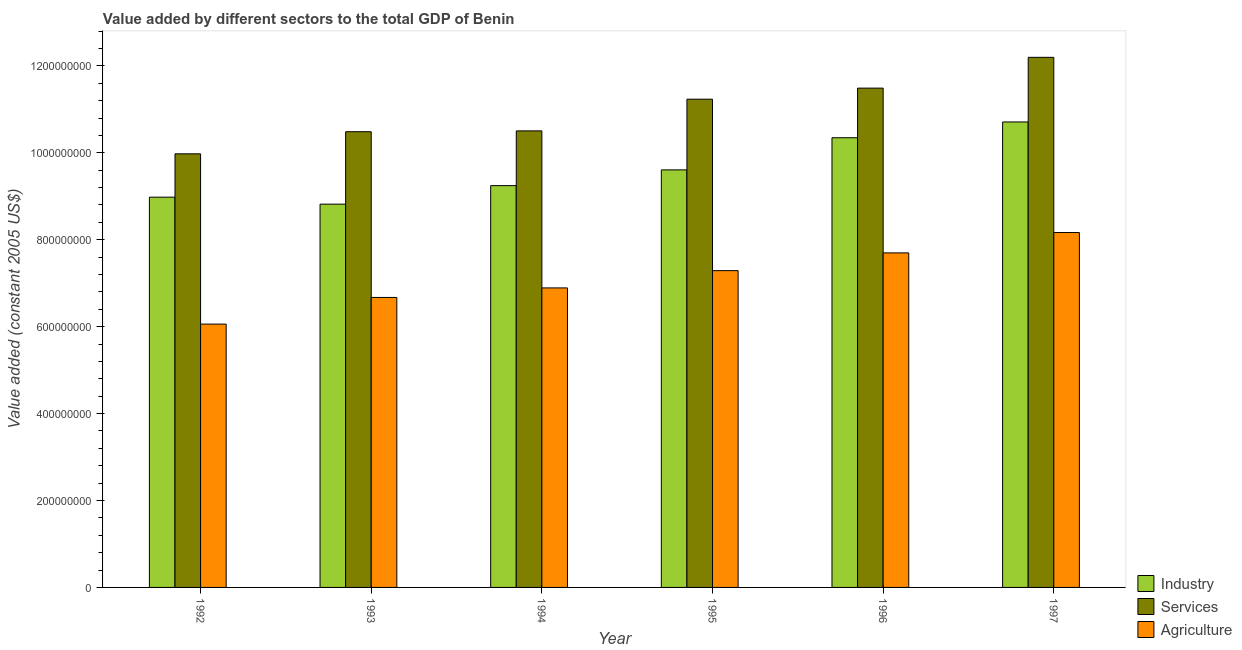How many different coloured bars are there?
Offer a very short reply. 3. Are the number of bars per tick equal to the number of legend labels?
Keep it short and to the point. Yes. What is the label of the 5th group of bars from the left?
Keep it short and to the point. 1996. What is the value added by agricultural sector in 1992?
Make the answer very short. 6.06e+08. Across all years, what is the maximum value added by agricultural sector?
Ensure brevity in your answer.  8.17e+08. Across all years, what is the minimum value added by services?
Give a very brief answer. 9.98e+08. In which year was the value added by industrial sector maximum?
Keep it short and to the point. 1997. In which year was the value added by industrial sector minimum?
Keep it short and to the point. 1993. What is the total value added by services in the graph?
Make the answer very short. 6.59e+09. What is the difference between the value added by agricultural sector in 1994 and that in 1995?
Offer a terse response. -3.97e+07. What is the difference between the value added by industrial sector in 1993 and the value added by services in 1995?
Provide a short and direct response. -7.89e+07. What is the average value added by industrial sector per year?
Keep it short and to the point. 9.62e+08. In the year 1993, what is the difference between the value added by agricultural sector and value added by industrial sector?
Ensure brevity in your answer.  0. In how many years, is the value added by industrial sector greater than 280000000 US$?
Ensure brevity in your answer.  6. What is the ratio of the value added by services in 1994 to that in 1996?
Keep it short and to the point. 0.91. What is the difference between the highest and the second highest value added by agricultural sector?
Your response must be concise. 4.68e+07. What is the difference between the highest and the lowest value added by industrial sector?
Keep it short and to the point. 1.89e+08. In how many years, is the value added by agricultural sector greater than the average value added by agricultural sector taken over all years?
Your answer should be compact. 3. What does the 2nd bar from the left in 1996 represents?
Provide a short and direct response. Services. What does the 3rd bar from the right in 1994 represents?
Provide a succinct answer. Industry. How are the legend labels stacked?
Ensure brevity in your answer.  Vertical. What is the title of the graph?
Your answer should be compact. Value added by different sectors to the total GDP of Benin. Does "New Zealand" appear as one of the legend labels in the graph?
Provide a short and direct response. No. What is the label or title of the X-axis?
Offer a terse response. Year. What is the label or title of the Y-axis?
Provide a succinct answer. Value added (constant 2005 US$). What is the Value added (constant 2005 US$) in Industry in 1992?
Make the answer very short. 8.98e+08. What is the Value added (constant 2005 US$) of Services in 1992?
Keep it short and to the point. 9.98e+08. What is the Value added (constant 2005 US$) of Agriculture in 1992?
Ensure brevity in your answer.  6.06e+08. What is the Value added (constant 2005 US$) of Industry in 1993?
Keep it short and to the point. 8.82e+08. What is the Value added (constant 2005 US$) of Services in 1993?
Make the answer very short. 1.05e+09. What is the Value added (constant 2005 US$) in Agriculture in 1993?
Make the answer very short. 6.67e+08. What is the Value added (constant 2005 US$) in Industry in 1994?
Your response must be concise. 9.25e+08. What is the Value added (constant 2005 US$) in Services in 1994?
Offer a very short reply. 1.05e+09. What is the Value added (constant 2005 US$) of Agriculture in 1994?
Keep it short and to the point. 6.89e+08. What is the Value added (constant 2005 US$) in Industry in 1995?
Keep it short and to the point. 9.61e+08. What is the Value added (constant 2005 US$) of Services in 1995?
Provide a succinct answer. 1.12e+09. What is the Value added (constant 2005 US$) in Agriculture in 1995?
Offer a very short reply. 7.29e+08. What is the Value added (constant 2005 US$) of Industry in 1996?
Give a very brief answer. 1.03e+09. What is the Value added (constant 2005 US$) of Services in 1996?
Provide a short and direct response. 1.15e+09. What is the Value added (constant 2005 US$) of Agriculture in 1996?
Offer a terse response. 7.70e+08. What is the Value added (constant 2005 US$) in Industry in 1997?
Provide a succinct answer. 1.07e+09. What is the Value added (constant 2005 US$) of Services in 1997?
Offer a very short reply. 1.22e+09. What is the Value added (constant 2005 US$) in Agriculture in 1997?
Your answer should be very brief. 8.17e+08. Across all years, what is the maximum Value added (constant 2005 US$) of Industry?
Offer a very short reply. 1.07e+09. Across all years, what is the maximum Value added (constant 2005 US$) in Services?
Offer a very short reply. 1.22e+09. Across all years, what is the maximum Value added (constant 2005 US$) in Agriculture?
Ensure brevity in your answer.  8.17e+08. Across all years, what is the minimum Value added (constant 2005 US$) in Industry?
Offer a terse response. 8.82e+08. Across all years, what is the minimum Value added (constant 2005 US$) in Services?
Provide a short and direct response. 9.98e+08. Across all years, what is the minimum Value added (constant 2005 US$) in Agriculture?
Your answer should be very brief. 6.06e+08. What is the total Value added (constant 2005 US$) in Industry in the graph?
Make the answer very short. 5.77e+09. What is the total Value added (constant 2005 US$) in Services in the graph?
Ensure brevity in your answer.  6.59e+09. What is the total Value added (constant 2005 US$) of Agriculture in the graph?
Provide a succinct answer. 4.28e+09. What is the difference between the Value added (constant 2005 US$) of Industry in 1992 and that in 1993?
Offer a very short reply. 1.61e+07. What is the difference between the Value added (constant 2005 US$) of Services in 1992 and that in 1993?
Your answer should be compact. -5.09e+07. What is the difference between the Value added (constant 2005 US$) in Agriculture in 1992 and that in 1993?
Offer a very short reply. -6.14e+07. What is the difference between the Value added (constant 2005 US$) in Industry in 1992 and that in 1994?
Provide a short and direct response. -2.65e+07. What is the difference between the Value added (constant 2005 US$) of Services in 1992 and that in 1994?
Provide a short and direct response. -5.28e+07. What is the difference between the Value added (constant 2005 US$) in Agriculture in 1992 and that in 1994?
Offer a very short reply. -8.33e+07. What is the difference between the Value added (constant 2005 US$) of Industry in 1992 and that in 1995?
Ensure brevity in your answer.  -6.28e+07. What is the difference between the Value added (constant 2005 US$) in Services in 1992 and that in 1995?
Your answer should be very brief. -1.26e+08. What is the difference between the Value added (constant 2005 US$) of Agriculture in 1992 and that in 1995?
Your answer should be compact. -1.23e+08. What is the difference between the Value added (constant 2005 US$) in Industry in 1992 and that in 1996?
Keep it short and to the point. -1.37e+08. What is the difference between the Value added (constant 2005 US$) in Services in 1992 and that in 1996?
Your answer should be very brief. -1.51e+08. What is the difference between the Value added (constant 2005 US$) of Agriculture in 1992 and that in 1996?
Offer a terse response. -1.64e+08. What is the difference between the Value added (constant 2005 US$) in Industry in 1992 and that in 1997?
Your answer should be compact. -1.73e+08. What is the difference between the Value added (constant 2005 US$) in Services in 1992 and that in 1997?
Provide a succinct answer. -2.22e+08. What is the difference between the Value added (constant 2005 US$) of Agriculture in 1992 and that in 1997?
Make the answer very short. -2.11e+08. What is the difference between the Value added (constant 2005 US$) in Industry in 1993 and that in 1994?
Ensure brevity in your answer.  -4.26e+07. What is the difference between the Value added (constant 2005 US$) of Services in 1993 and that in 1994?
Your answer should be very brief. -1.88e+06. What is the difference between the Value added (constant 2005 US$) in Agriculture in 1993 and that in 1994?
Offer a terse response. -2.19e+07. What is the difference between the Value added (constant 2005 US$) in Industry in 1993 and that in 1995?
Make the answer very short. -7.89e+07. What is the difference between the Value added (constant 2005 US$) in Services in 1993 and that in 1995?
Provide a short and direct response. -7.48e+07. What is the difference between the Value added (constant 2005 US$) in Agriculture in 1993 and that in 1995?
Make the answer very short. -6.16e+07. What is the difference between the Value added (constant 2005 US$) in Industry in 1993 and that in 1996?
Ensure brevity in your answer.  -1.53e+08. What is the difference between the Value added (constant 2005 US$) of Services in 1993 and that in 1996?
Make the answer very short. -1.00e+08. What is the difference between the Value added (constant 2005 US$) of Agriculture in 1993 and that in 1996?
Make the answer very short. -1.02e+08. What is the difference between the Value added (constant 2005 US$) in Industry in 1993 and that in 1997?
Your answer should be compact. -1.89e+08. What is the difference between the Value added (constant 2005 US$) in Services in 1993 and that in 1997?
Keep it short and to the point. -1.71e+08. What is the difference between the Value added (constant 2005 US$) of Agriculture in 1993 and that in 1997?
Provide a short and direct response. -1.49e+08. What is the difference between the Value added (constant 2005 US$) in Industry in 1994 and that in 1995?
Give a very brief answer. -3.63e+07. What is the difference between the Value added (constant 2005 US$) of Services in 1994 and that in 1995?
Provide a succinct answer. -7.29e+07. What is the difference between the Value added (constant 2005 US$) of Agriculture in 1994 and that in 1995?
Keep it short and to the point. -3.97e+07. What is the difference between the Value added (constant 2005 US$) in Industry in 1994 and that in 1996?
Offer a terse response. -1.10e+08. What is the difference between the Value added (constant 2005 US$) in Services in 1994 and that in 1996?
Your answer should be very brief. -9.84e+07. What is the difference between the Value added (constant 2005 US$) in Agriculture in 1994 and that in 1996?
Ensure brevity in your answer.  -8.06e+07. What is the difference between the Value added (constant 2005 US$) of Industry in 1994 and that in 1997?
Provide a short and direct response. -1.46e+08. What is the difference between the Value added (constant 2005 US$) in Services in 1994 and that in 1997?
Make the answer very short. -1.69e+08. What is the difference between the Value added (constant 2005 US$) in Agriculture in 1994 and that in 1997?
Ensure brevity in your answer.  -1.27e+08. What is the difference between the Value added (constant 2005 US$) of Industry in 1995 and that in 1996?
Offer a terse response. -7.39e+07. What is the difference between the Value added (constant 2005 US$) of Services in 1995 and that in 1996?
Your answer should be compact. -2.54e+07. What is the difference between the Value added (constant 2005 US$) of Agriculture in 1995 and that in 1996?
Provide a short and direct response. -4.08e+07. What is the difference between the Value added (constant 2005 US$) of Industry in 1995 and that in 1997?
Ensure brevity in your answer.  -1.10e+08. What is the difference between the Value added (constant 2005 US$) of Services in 1995 and that in 1997?
Provide a short and direct response. -9.63e+07. What is the difference between the Value added (constant 2005 US$) in Agriculture in 1995 and that in 1997?
Offer a terse response. -8.77e+07. What is the difference between the Value added (constant 2005 US$) in Industry in 1996 and that in 1997?
Give a very brief answer. -3.63e+07. What is the difference between the Value added (constant 2005 US$) in Services in 1996 and that in 1997?
Ensure brevity in your answer.  -7.09e+07. What is the difference between the Value added (constant 2005 US$) of Agriculture in 1996 and that in 1997?
Make the answer very short. -4.68e+07. What is the difference between the Value added (constant 2005 US$) of Industry in 1992 and the Value added (constant 2005 US$) of Services in 1993?
Give a very brief answer. -1.51e+08. What is the difference between the Value added (constant 2005 US$) of Industry in 1992 and the Value added (constant 2005 US$) of Agriculture in 1993?
Your answer should be very brief. 2.31e+08. What is the difference between the Value added (constant 2005 US$) of Services in 1992 and the Value added (constant 2005 US$) of Agriculture in 1993?
Provide a succinct answer. 3.30e+08. What is the difference between the Value added (constant 2005 US$) of Industry in 1992 and the Value added (constant 2005 US$) of Services in 1994?
Provide a short and direct response. -1.52e+08. What is the difference between the Value added (constant 2005 US$) of Industry in 1992 and the Value added (constant 2005 US$) of Agriculture in 1994?
Make the answer very short. 2.09e+08. What is the difference between the Value added (constant 2005 US$) of Services in 1992 and the Value added (constant 2005 US$) of Agriculture in 1994?
Keep it short and to the point. 3.09e+08. What is the difference between the Value added (constant 2005 US$) of Industry in 1992 and the Value added (constant 2005 US$) of Services in 1995?
Your answer should be very brief. -2.25e+08. What is the difference between the Value added (constant 2005 US$) of Industry in 1992 and the Value added (constant 2005 US$) of Agriculture in 1995?
Your answer should be very brief. 1.69e+08. What is the difference between the Value added (constant 2005 US$) in Services in 1992 and the Value added (constant 2005 US$) in Agriculture in 1995?
Offer a terse response. 2.69e+08. What is the difference between the Value added (constant 2005 US$) in Industry in 1992 and the Value added (constant 2005 US$) in Services in 1996?
Make the answer very short. -2.51e+08. What is the difference between the Value added (constant 2005 US$) in Industry in 1992 and the Value added (constant 2005 US$) in Agriculture in 1996?
Keep it short and to the point. 1.28e+08. What is the difference between the Value added (constant 2005 US$) in Services in 1992 and the Value added (constant 2005 US$) in Agriculture in 1996?
Keep it short and to the point. 2.28e+08. What is the difference between the Value added (constant 2005 US$) in Industry in 1992 and the Value added (constant 2005 US$) in Services in 1997?
Offer a very short reply. -3.22e+08. What is the difference between the Value added (constant 2005 US$) of Industry in 1992 and the Value added (constant 2005 US$) of Agriculture in 1997?
Keep it short and to the point. 8.14e+07. What is the difference between the Value added (constant 2005 US$) of Services in 1992 and the Value added (constant 2005 US$) of Agriculture in 1997?
Your answer should be very brief. 1.81e+08. What is the difference between the Value added (constant 2005 US$) of Industry in 1993 and the Value added (constant 2005 US$) of Services in 1994?
Keep it short and to the point. -1.69e+08. What is the difference between the Value added (constant 2005 US$) in Industry in 1993 and the Value added (constant 2005 US$) in Agriculture in 1994?
Offer a very short reply. 1.93e+08. What is the difference between the Value added (constant 2005 US$) of Services in 1993 and the Value added (constant 2005 US$) of Agriculture in 1994?
Keep it short and to the point. 3.59e+08. What is the difference between the Value added (constant 2005 US$) in Industry in 1993 and the Value added (constant 2005 US$) in Services in 1995?
Provide a succinct answer. -2.42e+08. What is the difference between the Value added (constant 2005 US$) in Industry in 1993 and the Value added (constant 2005 US$) in Agriculture in 1995?
Your answer should be compact. 1.53e+08. What is the difference between the Value added (constant 2005 US$) of Services in 1993 and the Value added (constant 2005 US$) of Agriculture in 1995?
Offer a terse response. 3.20e+08. What is the difference between the Value added (constant 2005 US$) in Industry in 1993 and the Value added (constant 2005 US$) in Services in 1996?
Offer a terse response. -2.67e+08. What is the difference between the Value added (constant 2005 US$) of Industry in 1993 and the Value added (constant 2005 US$) of Agriculture in 1996?
Make the answer very short. 1.12e+08. What is the difference between the Value added (constant 2005 US$) in Services in 1993 and the Value added (constant 2005 US$) in Agriculture in 1996?
Give a very brief answer. 2.79e+08. What is the difference between the Value added (constant 2005 US$) of Industry in 1993 and the Value added (constant 2005 US$) of Services in 1997?
Offer a very short reply. -3.38e+08. What is the difference between the Value added (constant 2005 US$) of Industry in 1993 and the Value added (constant 2005 US$) of Agriculture in 1997?
Make the answer very short. 6.53e+07. What is the difference between the Value added (constant 2005 US$) of Services in 1993 and the Value added (constant 2005 US$) of Agriculture in 1997?
Provide a succinct answer. 2.32e+08. What is the difference between the Value added (constant 2005 US$) of Industry in 1994 and the Value added (constant 2005 US$) of Services in 1995?
Ensure brevity in your answer.  -1.99e+08. What is the difference between the Value added (constant 2005 US$) of Industry in 1994 and the Value added (constant 2005 US$) of Agriculture in 1995?
Provide a succinct answer. 1.96e+08. What is the difference between the Value added (constant 2005 US$) of Services in 1994 and the Value added (constant 2005 US$) of Agriculture in 1995?
Your answer should be very brief. 3.22e+08. What is the difference between the Value added (constant 2005 US$) of Industry in 1994 and the Value added (constant 2005 US$) of Services in 1996?
Offer a very short reply. -2.24e+08. What is the difference between the Value added (constant 2005 US$) of Industry in 1994 and the Value added (constant 2005 US$) of Agriculture in 1996?
Provide a succinct answer. 1.55e+08. What is the difference between the Value added (constant 2005 US$) of Services in 1994 and the Value added (constant 2005 US$) of Agriculture in 1996?
Offer a terse response. 2.81e+08. What is the difference between the Value added (constant 2005 US$) of Industry in 1994 and the Value added (constant 2005 US$) of Services in 1997?
Keep it short and to the point. -2.95e+08. What is the difference between the Value added (constant 2005 US$) in Industry in 1994 and the Value added (constant 2005 US$) in Agriculture in 1997?
Give a very brief answer. 1.08e+08. What is the difference between the Value added (constant 2005 US$) in Services in 1994 and the Value added (constant 2005 US$) in Agriculture in 1997?
Your answer should be very brief. 2.34e+08. What is the difference between the Value added (constant 2005 US$) in Industry in 1995 and the Value added (constant 2005 US$) in Services in 1996?
Provide a succinct answer. -1.88e+08. What is the difference between the Value added (constant 2005 US$) of Industry in 1995 and the Value added (constant 2005 US$) of Agriculture in 1996?
Give a very brief answer. 1.91e+08. What is the difference between the Value added (constant 2005 US$) in Services in 1995 and the Value added (constant 2005 US$) in Agriculture in 1996?
Your answer should be compact. 3.54e+08. What is the difference between the Value added (constant 2005 US$) in Industry in 1995 and the Value added (constant 2005 US$) in Services in 1997?
Your answer should be compact. -2.59e+08. What is the difference between the Value added (constant 2005 US$) in Industry in 1995 and the Value added (constant 2005 US$) in Agriculture in 1997?
Provide a succinct answer. 1.44e+08. What is the difference between the Value added (constant 2005 US$) of Services in 1995 and the Value added (constant 2005 US$) of Agriculture in 1997?
Provide a succinct answer. 3.07e+08. What is the difference between the Value added (constant 2005 US$) of Industry in 1996 and the Value added (constant 2005 US$) of Services in 1997?
Offer a very short reply. -1.85e+08. What is the difference between the Value added (constant 2005 US$) in Industry in 1996 and the Value added (constant 2005 US$) in Agriculture in 1997?
Offer a very short reply. 2.18e+08. What is the difference between the Value added (constant 2005 US$) in Services in 1996 and the Value added (constant 2005 US$) in Agriculture in 1997?
Keep it short and to the point. 3.32e+08. What is the average Value added (constant 2005 US$) of Industry per year?
Your answer should be very brief. 9.62e+08. What is the average Value added (constant 2005 US$) of Services per year?
Your answer should be very brief. 1.10e+09. What is the average Value added (constant 2005 US$) of Agriculture per year?
Ensure brevity in your answer.  7.13e+08. In the year 1992, what is the difference between the Value added (constant 2005 US$) in Industry and Value added (constant 2005 US$) in Services?
Give a very brief answer. -9.97e+07. In the year 1992, what is the difference between the Value added (constant 2005 US$) of Industry and Value added (constant 2005 US$) of Agriculture?
Ensure brevity in your answer.  2.92e+08. In the year 1992, what is the difference between the Value added (constant 2005 US$) in Services and Value added (constant 2005 US$) in Agriculture?
Keep it short and to the point. 3.92e+08. In the year 1993, what is the difference between the Value added (constant 2005 US$) in Industry and Value added (constant 2005 US$) in Services?
Provide a succinct answer. -1.67e+08. In the year 1993, what is the difference between the Value added (constant 2005 US$) in Industry and Value added (constant 2005 US$) in Agriculture?
Make the answer very short. 2.15e+08. In the year 1993, what is the difference between the Value added (constant 2005 US$) of Services and Value added (constant 2005 US$) of Agriculture?
Provide a succinct answer. 3.81e+08. In the year 1994, what is the difference between the Value added (constant 2005 US$) of Industry and Value added (constant 2005 US$) of Services?
Offer a terse response. -1.26e+08. In the year 1994, what is the difference between the Value added (constant 2005 US$) in Industry and Value added (constant 2005 US$) in Agriculture?
Make the answer very short. 2.35e+08. In the year 1994, what is the difference between the Value added (constant 2005 US$) of Services and Value added (constant 2005 US$) of Agriculture?
Your response must be concise. 3.61e+08. In the year 1995, what is the difference between the Value added (constant 2005 US$) in Industry and Value added (constant 2005 US$) in Services?
Your answer should be compact. -1.63e+08. In the year 1995, what is the difference between the Value added (constant 2005 US$) in Industry and Value added (constant 2005 US$) in Agriculture?
Provide a succinct answer. 2.32e+08. In the year 1995, what is the difference between the Value added (constant 2005 US$) of Services and Value added (constant 2005 US$) of Agriculture?
Provide a short and direct response. 3.95e+08. In the year 1996, what is the difference between the Value added (constant 2005 US$) of Industry and Value added (constant 2005 US$) of Services?
Offer a terse response. -1.14e+08. In the year 1996, what is the difference between the Value added (constant 2005 US$) in Industry and Value added (constant 2005 US$) in Agriculture?
Provide a succinct answer. 2.65e+08. In the year 1996, what is the difference between the Value added (constant 2005 US$) of Services and Value added (constant 2005 US$) of Agriculture?
Offer a very short reply. 3.79e+08. In the year 1997, what is the difference between the Value added (constant 2005 US$) of Industry and Value added (constant 2005 US$) of Services?
Your answer should be very brief. -1.49e+08. In the year 1997, what is the difference between the Value added (constant 2005 US$) in Industry and Value added (constant 2005 US$) in Agriculture?
Your answer should be compact. 2.54e+08. In the year 1997, what is the difference between the Value added (constant 2005 US$) in Services and Value added (constant 2005 US$) in Agriculture?
Keep it short and to the point. 4.03e+08. What is the ratio of the Value added (constant 2005 US$) in Industry in 1992 to that in 1993?
Your answer should be compact. 1.02. What is the ratio of the Value added (constant 2005 US$) of Services in 1992 to that in 1993?
Ensure brevity in your answer.  0.95. What is the ratio of the Value added (constant 2005 US$) of Agriculture in 1992 to that in 1993?
Your answer should be compact. 0.91. What is the ratio of the Value added (constant 2005 US$) of Industry in 1992 to that in 1994?
Your answer should be very brief. 0.97. What is the ratio of the Value added (constant 2005 US$) in Services in 1992 to that in 1994?
Make the answer very short. 0.95. What is the ratio of the Value added (constant 2005 US$) of Agriculture in 1992 to that in 1994?
Offer a terse response. 0.88. What is the ratio of the Value added (constant 2005 US$) in Industry in 1992 to that in 1995?
Provide a short and direct response. 0.93. What is the ratio of the Value added (constant 2005 US$) of Services in 1992 to that in 1995?
Give a very brief answer. 0.89. What is the ratio of the Value added (constant 2005 US$) of Agriculture in 1992 to that in 1995?
Keep it short and to the point. 0.83. What is the ratio of the Value added (constant 2005 US$) of Industry in 1992 to that in 1996?
Your response must be concise. 0.87. What is the ratio of the Value added (constant 2005 US$) in Services in 1992 to that in 1996?
Give a very brief answer. 0.87. What is the ratio of the Value added (constant 2005 US$) in Agriculture in 1992 to that in 1996?
Provide a short and direct response. 0.79. What is the ratio of the Value added (constant 2005 US$) in Industry in 1992 to that in 1997?
Your response must be concise. 0.84. What is the ratio of the Value added (constant 2005 US$) of Services in 1992 to that in 1997?
Give a very brief answer. 0.82. What is the ratio of the Value added (constant 2005 US$) in Agriculture in 1992 to that in 1997?
Give a very brief answer. 0.74. What is the ratio of the Value added (constant 2005 US$) of Industry in 1993 to that in 1994?
Offer a terse response. 0.95. What is the ratio of the Value added (constant 2005 US$) in Services in 1993 to that in 1994?
Give a very brief answer. 1. What is the ratio of the Value added (constant 2005 US$) in Agriculture in 1993 to that in 1994?
Keep it short and to the point. 0.97. What is the ratio of the Value added (constant 2005 US$) of Industry in 1993 to that in 1995?
Your response must be concise. 0.92. What is the ratio of the Value added (constant 2005 US$) of Services in 1993 to that in 1995?
Keep it short and to the point. 0.93. What is the ratio of the Value added (constant 2005 US$) in Agriculture in 1993 to that in 1995?
Your answer should be very brief. 0.92. What is the ratio of the Value added (constant 2005 US$) of Industry in 1993 to that in 1996?
Offer a terse response. 0.85. What is the ratio of the Value added (constant 2005 US$) in Services in 1993 to that in 1996?
Give a very brief answer. 0.91. What is the ratio of the Value added (constant 2005 US$) of Agriculture in 1993 to that in 1996?
Provide a succinct answer. 0.87. What is the ratio of the Value added (constant 2005 US$) in Industry in 1993 to that in 1997?
Your response must be concise. 0.82. What is the ratio of the Value added (constant 2005 US$) of Services in 1993 to that in 1997?
Your answer should be very brief. 0.86. What is the ratio of the Value added (constant 2005 US$) in Agriculture in 1993 to that in 1997?
Offer a terse response. 0.82. What is the ratio of the Value added (constant 2005 US$) of Industry in 1994 to that in 1995?
Give a very brief answer. 0.96. What is the ratio of the Value added (constant 2005 US$) of Services in 1994 to that in 1995?
Make the answer very short. 0.94. What is the ratio of the Value added (constant 2005 US$) of Agriculture in 1994 to that in 1995?
Provide a succinct answer. 0.95. What is the ratio of the Value added (constant 2005 US$) in Industry in 1994 to that in 1996?
Provide a succinct answer. 0.89. What is the ratio of the Value added (constant 2005 US$) in Services in 1994 to that in 1996?
Offer a terse response. 0.91. What is the ratio of the Value added (constant 2005 US$) of Agriculture in 1994 to that in 1996?
Your response must be concise. 0.9. What is the ratio of the Value added (constant 2005 US$) of Industry in 1994 to that in 1997?
Offer a very short reply. 0.86. What is the ratio of the Value added (constant 2005 US$) in Services in 1994 to that in 1997?
Provide a succinct answer. 0.86. What is the ratio of the Value added (constant 2005 US$) in Agriculture in 1994 to that in 1997?
Offer a very short reply. 0.84. What is the ratio of the Value added (constant 2005 US$) in Industry in 1995 to that in 1996?
Your response must be concise. 0.93. What is the ratio of the Value added (constant 2005 US$) in Services in 1995 to that in 1996?
Your response must be concise. 0.98. What is the ratio of the Value added (constant 2005 US$) in Agriculture in 1995 to that in 1996?
Your answer should be very brief. 0.95. What is the ratio of the Value added (constant 2005 US$) in Industry in 1995 to that in 1997?
Provide a succinct answer. 0.9. What is the ratio of the Value added (constant 2005 US$) of Services in 1995 to that in 1997?
Keep it short and to the point. 0.92. What is the ratio of the Value added (constant 2005 US$) of Agriculture in 1995 to that in 1997?
Ensure brevity in your answer.  0.89. What is the ratio of the Value added (constant 2005 US$) in Industry in 1996 to that in 1997?
Offer a very short reply. 0.97. What is the ratio of the Value added (constant 2005 US$) in Services in 1996 to that in 1997?
Ensure brevity in your answer.  0.94. What is the ratio of the Value added (constant 2005 US$) of Agriculture in 1996 to that in 1997?
Offer a very short reply. 0.94. What is the difference between the highest and the second highest Value added (constant 2005 US$) in Industry?
Your answer should be very brief. 3.63e+07. What is the difference between the highest and the second highest Value added (constant 2005 US$) in Services?
Ensure brevity in your answer.  7.09e+07. What is the difference between the highest and the second highest Value added (constant 2005 US$) of Agriculture?
Give a very brief answer. 4.68e+07. What is the difference between the highest and the lowest Value added (constant 2005 US$) of Industry?
Provide a short and direct response. 1.89e+08. What is the difference between the highest and the lowest Value added (constant 2005 US$) in Services?
Offer a terse response. 2.22e+08. What is the difference between the highest and the lowest Value added (constant 2005 US$) of Agriculture?
Ensure brevity in your answer.  2.11e+08. 